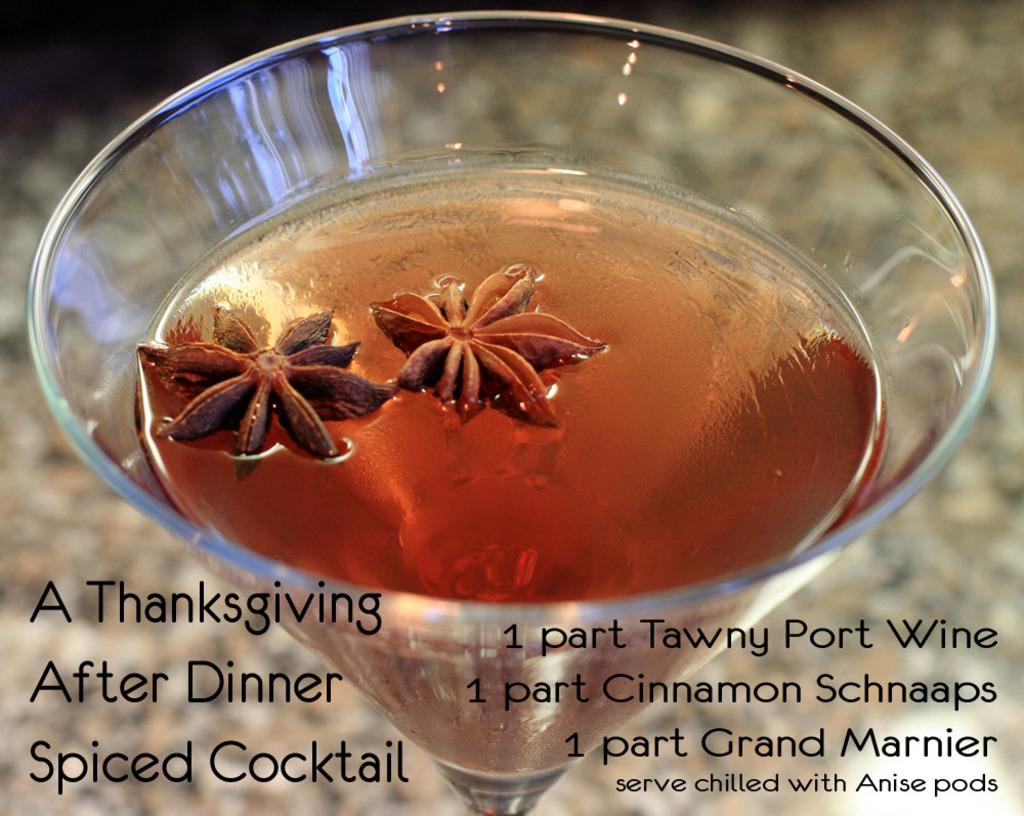What is contained in the glass that is visible in the image? There is a drink in the glass that is visible in the image. What additional information is provided below the image? There is text below the image. What type of steam is coming out of the glass in the image? There is no steam coming out of the glass in the image. What type of destruction is depicted in the image? There is no destruction depicted in the image; it only shows a glass with a drink and text below it. 